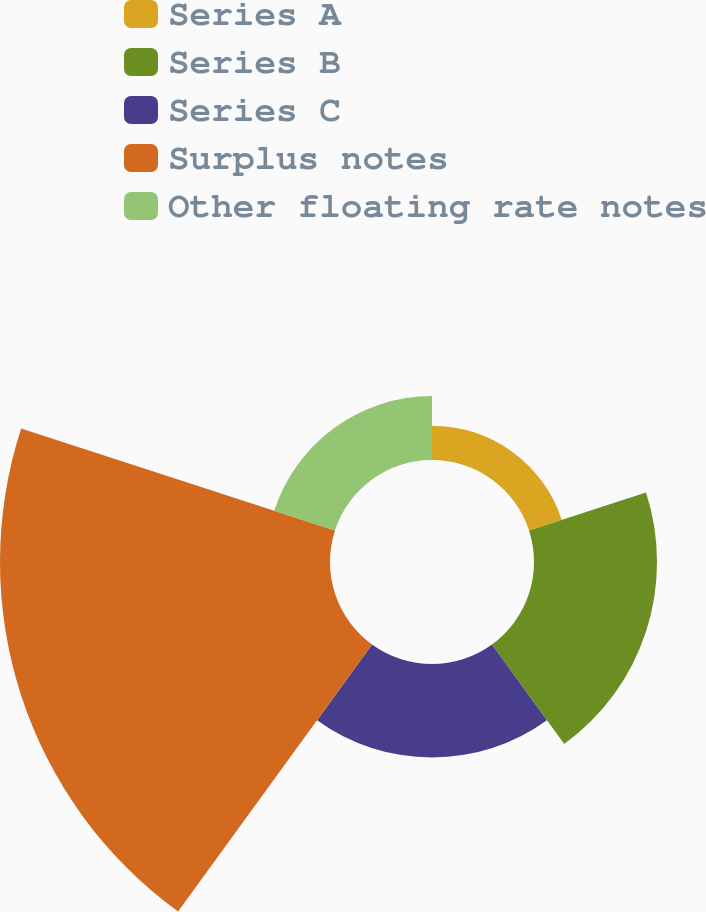<chart> <loc_0><loc_0><loc_500><loc_500><pie_chart><fcel>Series A<fcel>Series B<fcel>Series C<fcel>Surplus notes<fcel>Other floating rate notes<nl><fcel>5.33%<fcel>19.08%<fcel>14.5%<fcel>51.18%<fcel>9.91%<nl></chart> 